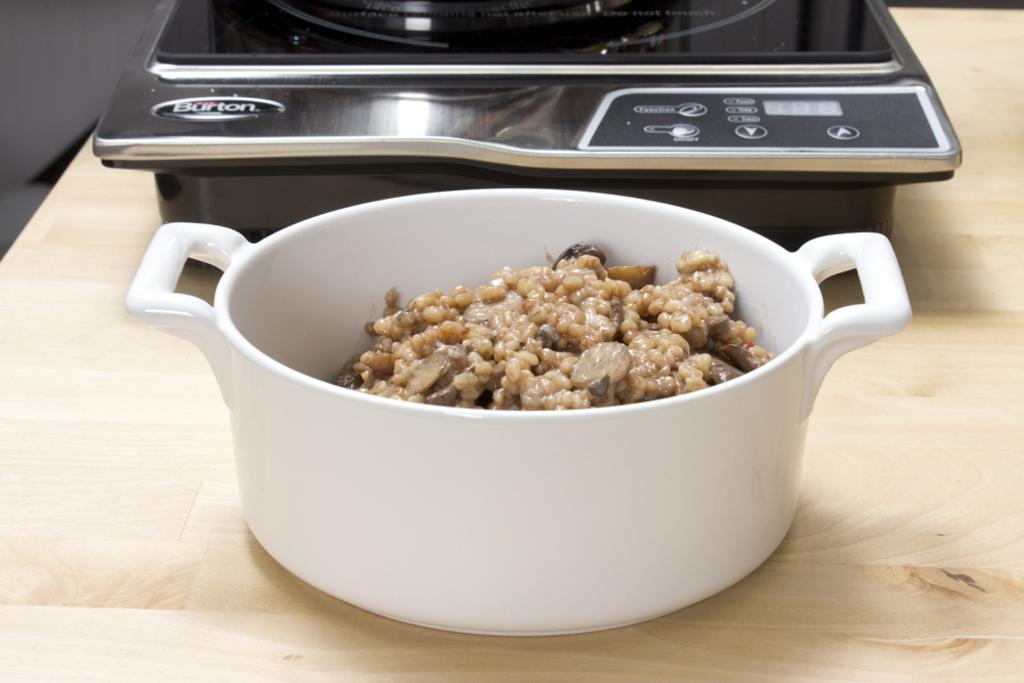Provide a one-sentence caption for the provided image. The equipment behind the meal is made by a company called Burton. 